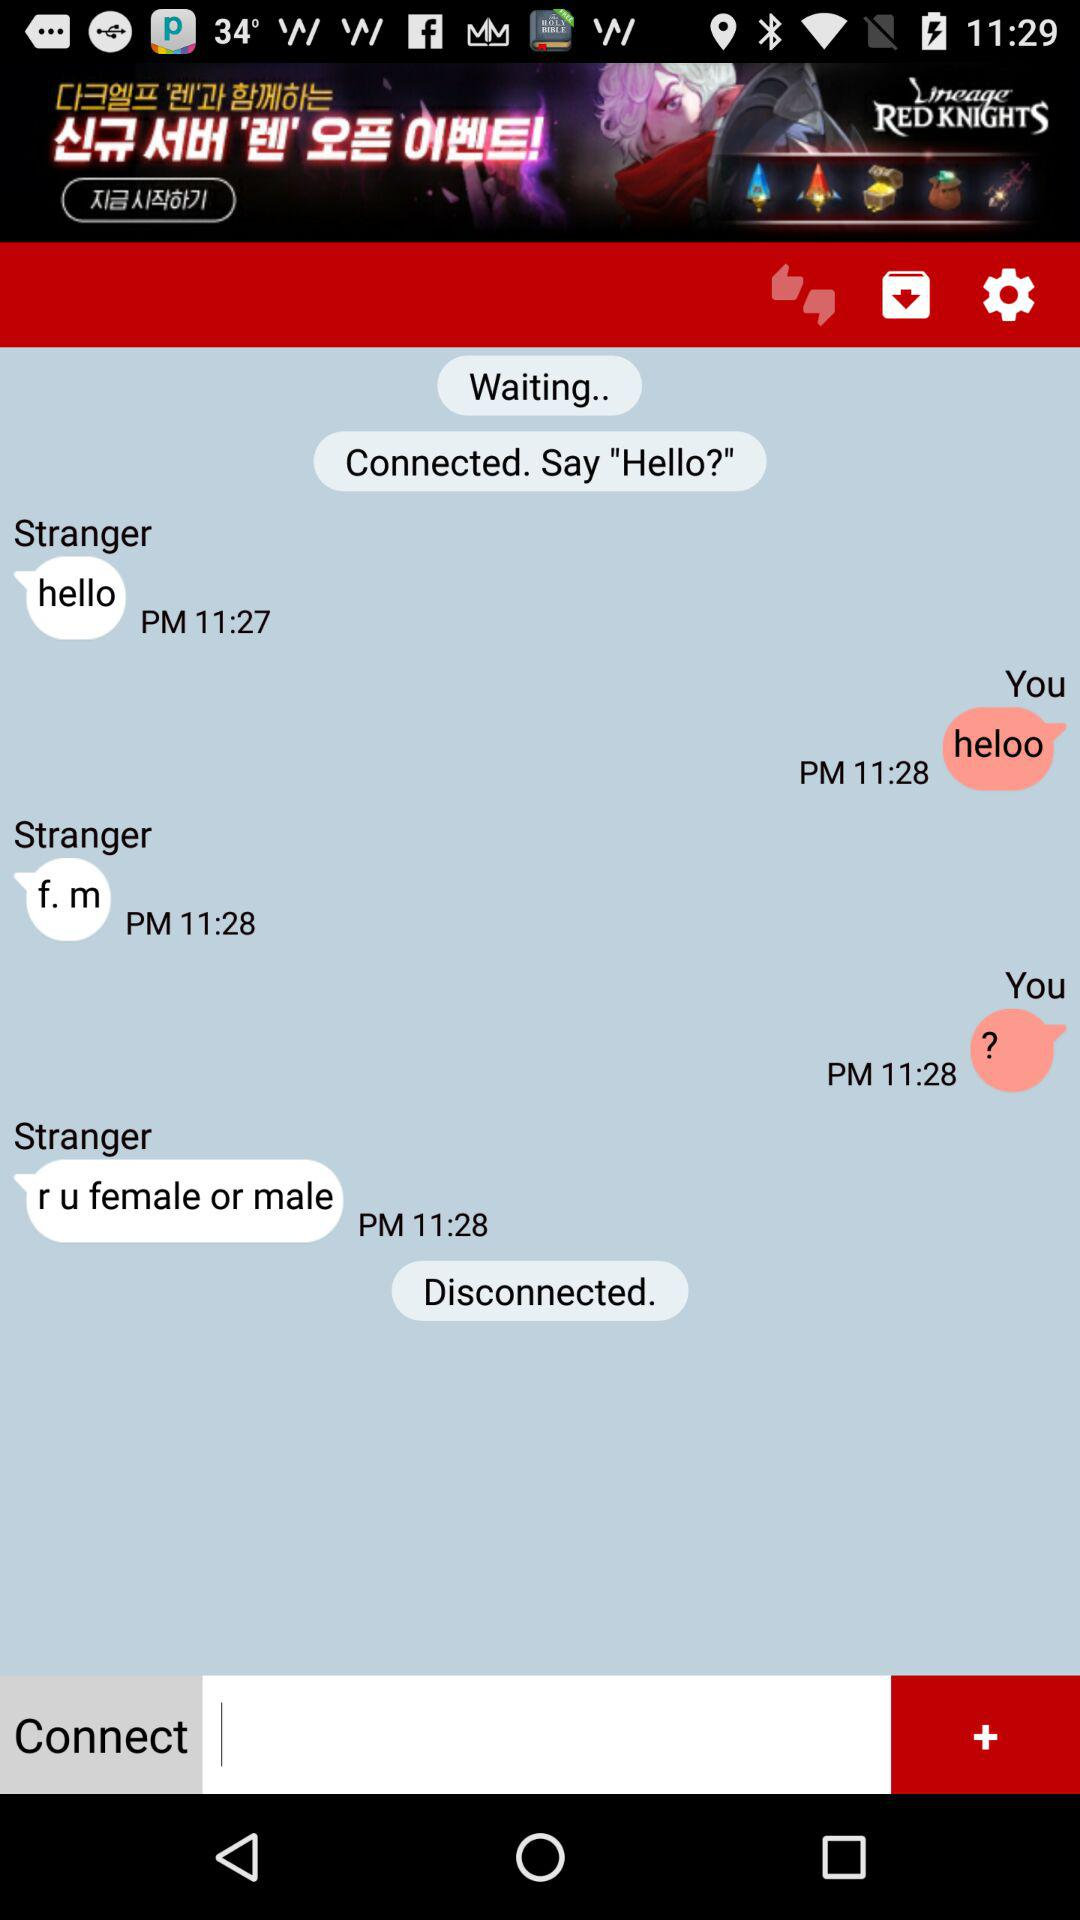What can we say when we connect? You can say "Hello?" when you connect. 